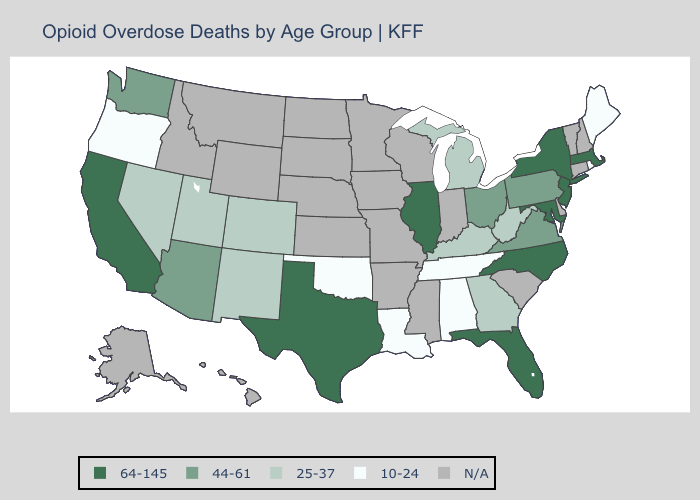Which states have the lowest value in the USA?
Give a very brief answer. Alabama, Louisiana, Maine, Oklahoma, Oregon, Rhode Island, Tennessee. Does Florida have the lowest value in the USA?
Write a very short answer. No. What is the lowest value in the South?
Short answer required. 10-24. What is the lowest value in the USA?
Write a very short answer. 10-24. What is the lowest value in the MidWest?
Give a very brief answer. 25-37. Which states hav the highest value in the Northeast?
Concise answer only. Massachusetts, New Jersey, New York. Name the states that have a value in the range 10-24?
Concise answer only. Alabama, Louisiana, Maine, Oklahoma, Oregon, Rhode Island, Tennessee. What is the value of Indiana?
Short answer required. N/A. Among the states that border Mississippi , which have the highest value?
Concise answer only. Alabama, Louisiana, Tennessee. Does the first symbol in the legend represent the smallest category?
Give a very brief answer. No. What is the lowest value in the USA?
Concise answer only. 10-24. Does Massachusetts have the lowest value in the Northeast?
Give a very brief answer. No. Name the states that have a value in the range 64-145?
Give a very brief answer. California, Florida, Illinois, Maryland, Massachusetts, New Jersey, New York, North Carolina, Texas. 